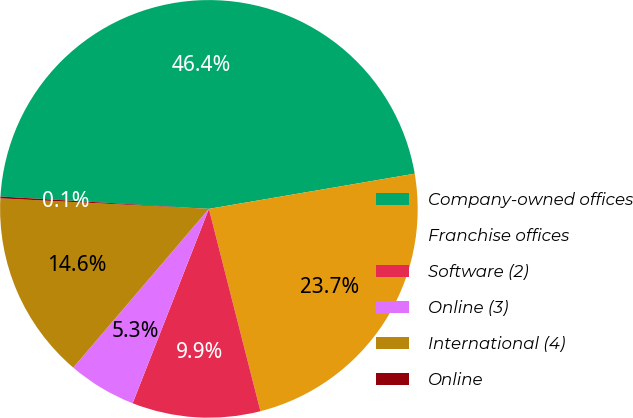Convert chart. <chart><loc_0><loc_0><loc_500><loc_500><pie_chart><fcel>Company-owned offices<fcel>Franchise offices<fcel>Software (2)<fcel>Online (3)<fcel>International (4)<fcel>Online<nl><fcel>46.36%<fcel>23.72%<fcel>9.92%<fcel>5.3%<fcel>14.55%<fcel>0.14%<nl></chart> 